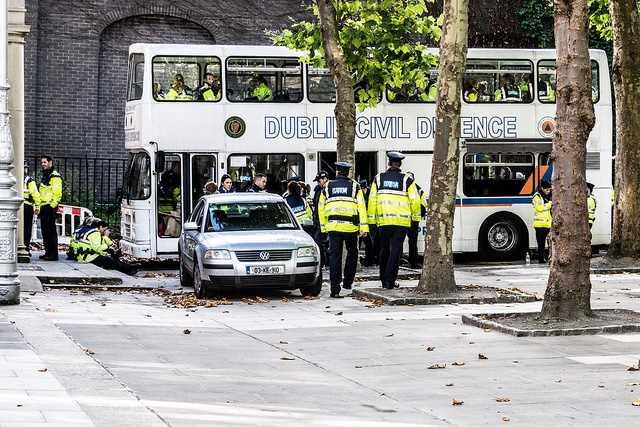Describe the objects in this image and their specific colors. I can see bus in white, lightgray, black, gray, and darkgray tones, car in white, black, gray, and darkgray tones, people in white, black, lightgray, yellow, and khaki tones, people in white, black, lightgray, khaki, and yellow tones, and people in white, black, yellow, and lightgray tones in this image. 